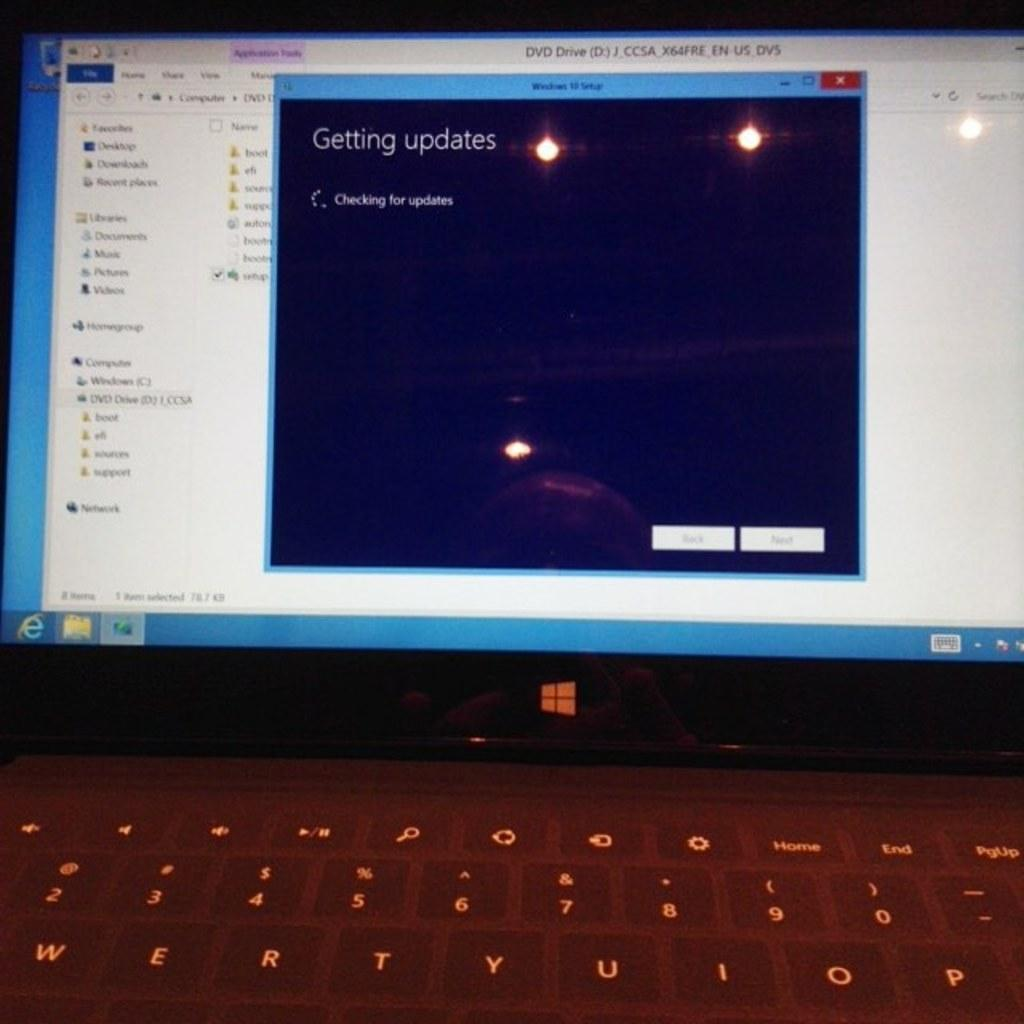What electronic device is visible in the image? There is a computer in the image. What is used to input data into the computer? There is a keyboard in the image. What feature can be seen on the computer? The computer has a window with lights. What is displayed on the window of the computer? There is text or something written on the window. Reasoning: Let' Let's think step by step in order to produce the conversation. We start by identifying the main electronic device in the image, which is the computer. Then, we mention the keyboard, which is a common input device for computers. Next, we describe a specific feature of the computer, which is the window with lights. Finally, we focus on the content displayed on the window, which is text or something written. Absurd Question/Answer: What type of car is parked next to the computer in the image? There is no car present in the image; it only features a computer and a keyboard. 